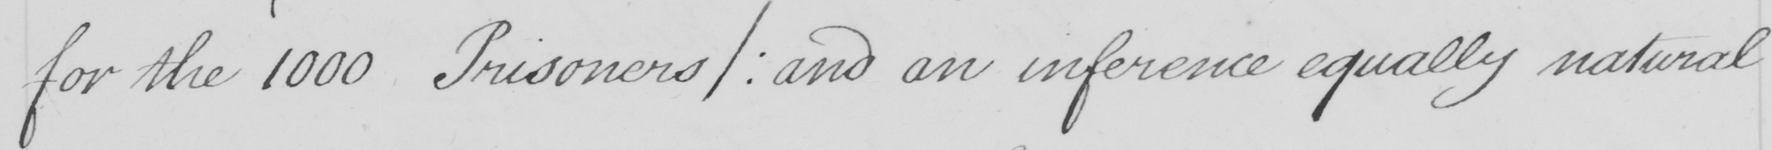What is written in this line of handwriting? for the 1000 Prisoners / :  and an inference equally natural 